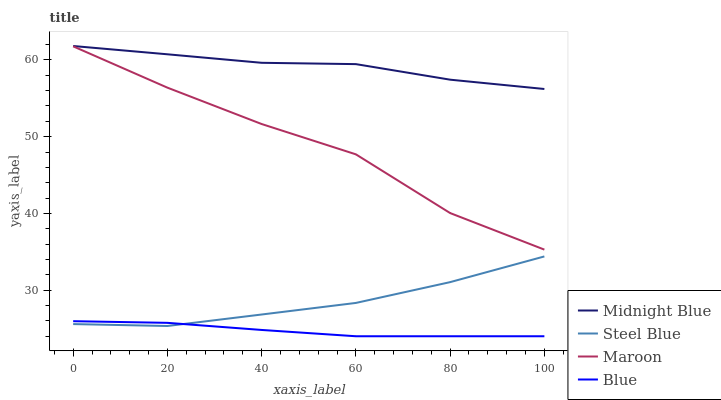Does Blue have the minimum area under the curve?
Answer yes or no. Yes. Does Midnight Blue have the maximum area under the curve?
Answer yes or no. Yes. Does Maroon have the minimum area under the curve?
Answer yes or no. No. Does Maroon have the maximum area under the curve?
Answer yes or no. No. Is Blue the smoothest?
Answer yes or no. Yes. Is Maroon the roughest?
Answer yes or no. Yes. Is Midnight Blue the smoothest?
Answer yes or no. No. Is Midnight Blue the roughest?
Answer yes or no. No. Does Blue have the lowest value?
Answer yes or no. Yes. Does Maroon have the lowest value?
Answer yes or no. No. Does Midnight Blue have the highest value?
Answer yes or no. Yes. Does Maroon have the highest value?
Answer yes or no. No. Is Steel Blue less than Maroon?
Answer yes or no. Yes. Is Midnight Blue greater than Blue?
Answer yes or no. Yes. Does Steel Blue intersect Blue?
Answer yes or no. Yes. Is Steel Blue less than Blue?
Answer yes or no. No. Is Steel Blue greater than Blue?
Answer yes or no. No. Does Steel Blue intersect Maroon?
Answer yes or no. No. 